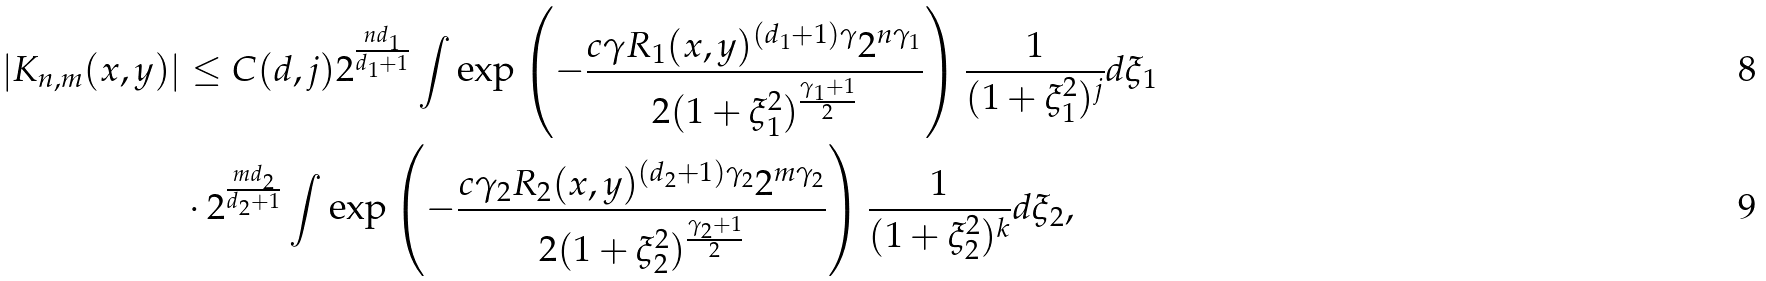<formula> <loc_0><loc_0><loc_500><loc_500>\left | K _ { n , m } ( x , y ) \right | & \leq C ( d , j ) 2 ^ { \frac { n d _ { 1 } } { d _ { 1 } + 1 } } \int \exp \left ( - \frac { c \gamma R _ { 1 } ( x , y ) ^ { ( d _ { 1 } + 1 ) \gamma } 2 ^ { n \gamma _ { 1 } } } { 2 ( 1 + \xi _ { 1 } ^ { 2 } ) ^ { \frac { \gamma _ { 1 } + 1 } { 2 } } } \right ) \frac { 1 } { ( 1 + \xi _ { 1 } ^ { 2 } ) ^ { j } } d \xi _ { 1 } \\ & \cdot 2 ^ { \frac { m d _ { 2 } } { d _ { 2 } + 1 } } \int \exp \left ( - \frac { c \gamma _ { 2 } R _ { 2 } ( x , y ) ^ { ( d _ { 2 } + 1 ) \gamma _ { 2 } } 2 ^ { m \gamma _ { 2 } } } { 2 ( 1 + \xi _ { 2 } ^ { 2 } ) ^ { \frac { \gamma _ { 2 } + 1 } { 2 } } } \right ) \frac { 1 } { ( 1 + \xi _ { 2 } ^ { 2 } ) ^ { k } } d \xi _ { 2 } ,</formula> 